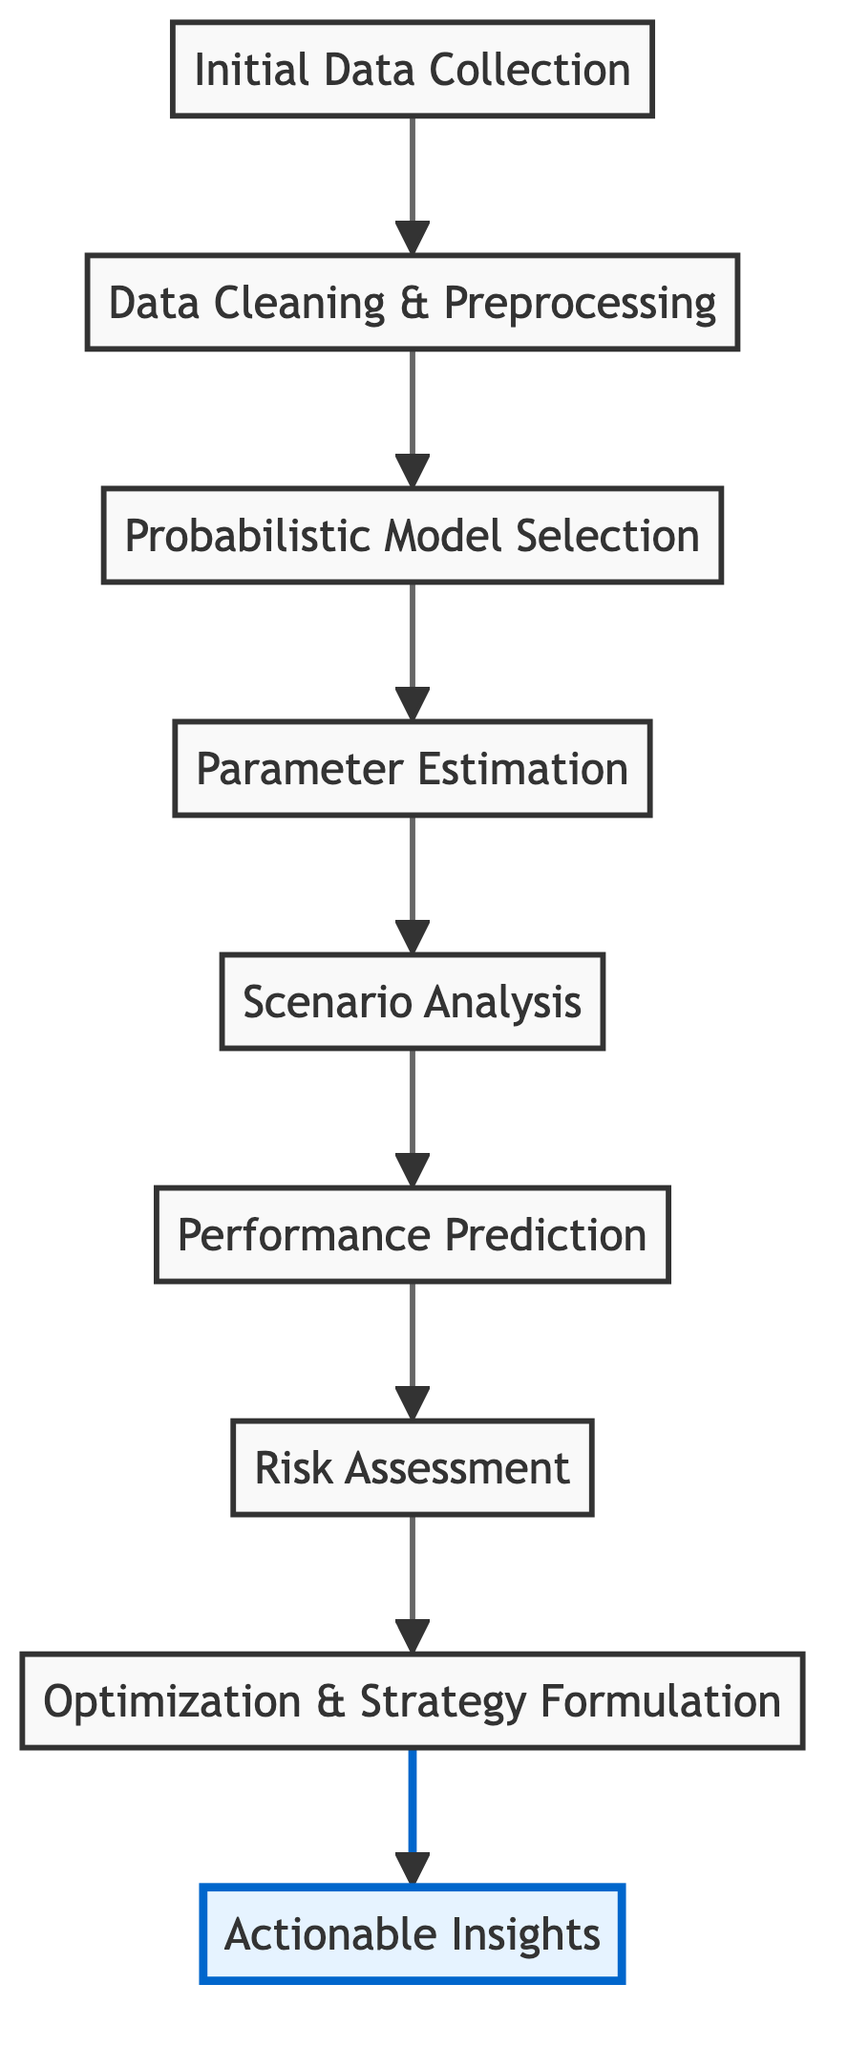What is the top node in the flow chart? The top node in this flow chart is "Actionable Insights," which represents the final step in the investment performance analysis process. You can see it positioned at the very top of the diagram, indicating that it is the ultimate outcome of the process.
Answer: Actionable Insights How many nodes are there in the diagram? The diagram contains nine distinct nodes, each representing a different step in the progression of investment performance analysis. This can be counted directly from the flow chart where each labeled box signifies a unique step.
Answer: Nine Which node follows "Parameter Estimation"? The node that follows "Parameter Estimation" is "Scenario Analysis." This relationship can be traced directly in the flow of the diagram by observing the arrow pointing upwards from "Parameter Estimation" to "Scenario Analysis."
Answer: Scenario Analysis What is the relationship between "Probabilistic Model Selection" and "Risk Assessment"? The relationship is that "Probabilistic Model Selection" precedes "Risk Assessment" in the flow. This means that the selection of probabilistic models is completed before evaluating risk metrics. Evidence of this relationship is found in the upward arrow connecting the two nodes.
Answer: Precedes How many steps are there between "Initial Data Collection" and "Optimization & Strategy Formulation"? There are six steps between "Initial Data Collection" and "Optimization & Strategy Formulation." Counting the nodes in between "Initial Data Collection" and "Optimization & Strategy Formulation" reveals the following steps: Data Cleaning & Preprocessing, Probabilistic Model Selection, Parameter Estimation, Scenario Analysis, Performance Prediction, and Risk Assessment.
Answer: Six Which step is associated with calculating expected returns? The step associated with calculating expected returns is "Parameter Estimation." This association is derived from the description provided for "Parameter Estimation," which explicitly mentions that it involves calculating parameters like expected returns.
Answer: Parameter Estimation What is the final operation in the flow chart? The final operation in the flow chart is "Actionable Insights," indicating that this step finalizes investment recommendations. Being the top node in the diagram underscores its position as the conclusion of the process.
Answer: Actionable Insights Which two nodes are directly linked to "Performance Prediction"? The two nodes directly linked to "Performance Prediction" are "Scenario Analysis" and "Risk Assessment." "Scenario Analysis" flows into "Performance Prediction," while "Performance Prediction" flows into "Risk Assessment," showcasing a sequential relationship between these steps.
Answer: Scenario Analysis and Risk Assessment What is the first step in the investment performance analysis process? The first step in the investment performance analysis process is "Initial Data Collection." This is indicated by its position at the bottom of the flow chart, representing the starting point of the entire analysis.
Answer: Initial Data Collection 